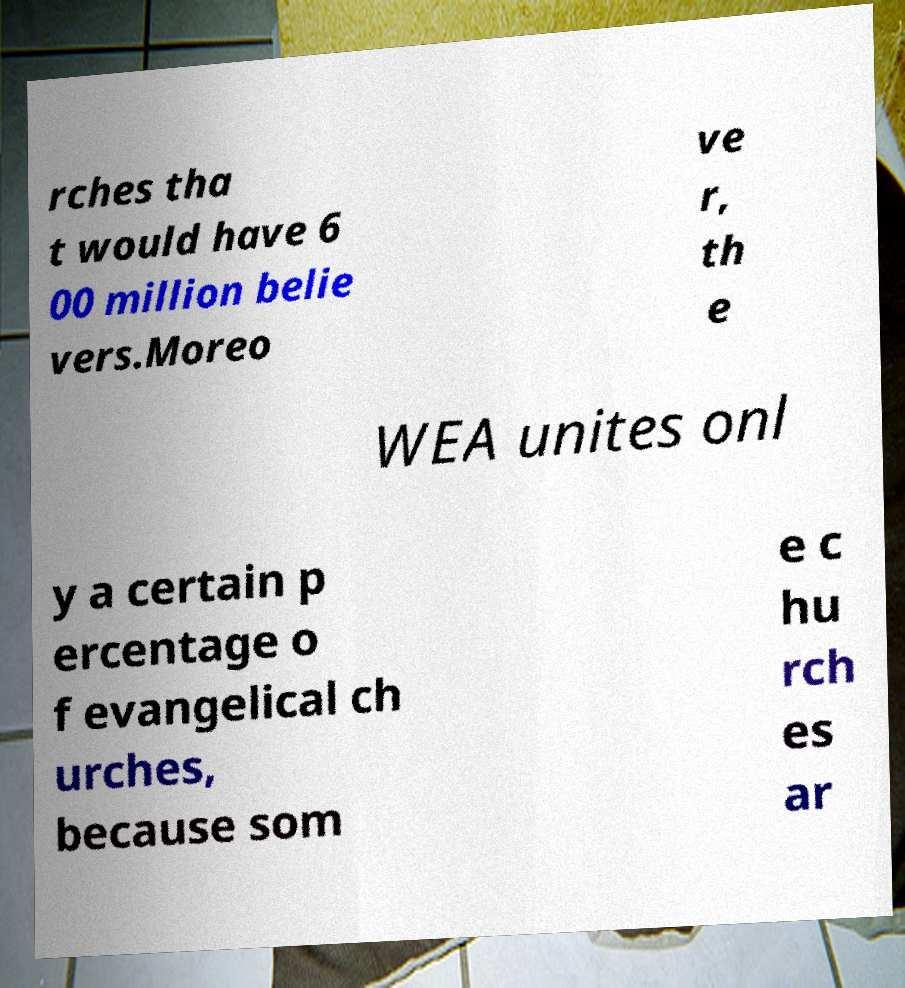I need the written content from this picture converted into text. Can you do that? rches tha t would have 6 00 million belie vers.Moreo ve r, th e WEA unites onl y a certain p ercentage o f evangelical ch urches, because som e c hu rch es ar 